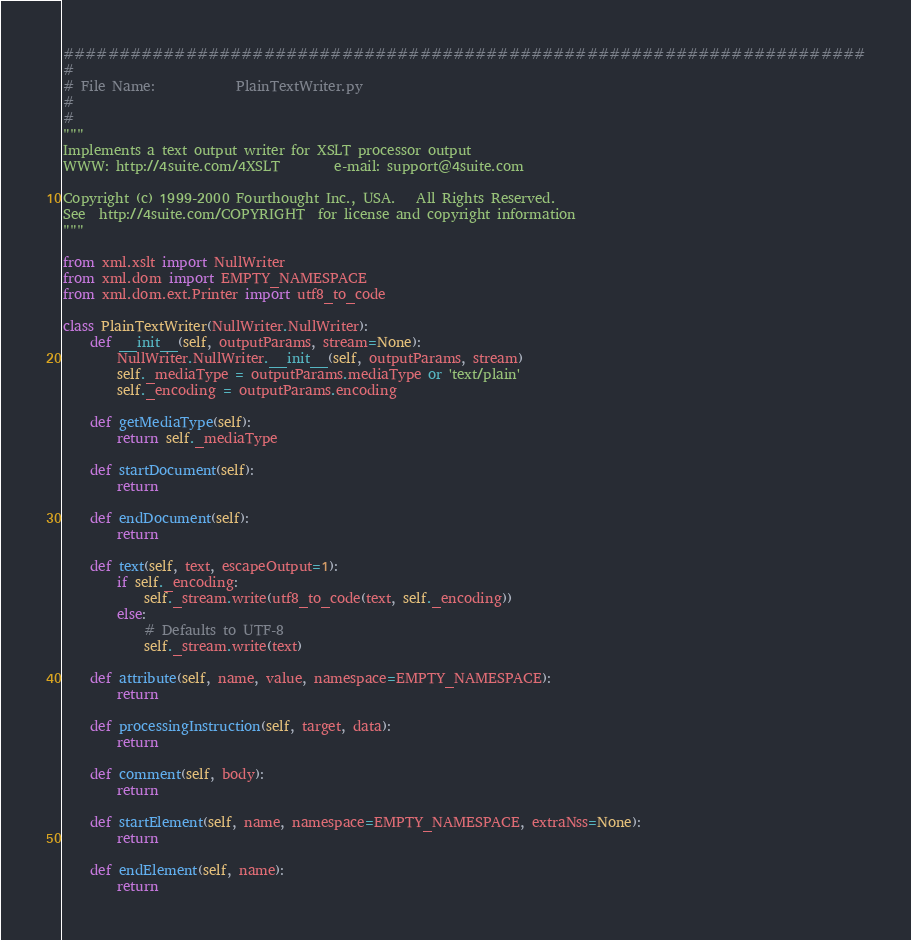<code> <loc_0><loc_0><loc_500><loc_500><_Python_>########################################################################
#
# File Name:            PlainTextWriter.py
#
#
"""
Implements a text output writer for XSLT processor output
WWW: http://4suite.com/4XSLT        e-mail: support@4suite.com

Copyright (c) 1999-2000 Fourthought Inc., USA.   All Rights Reserved.
See  http://4suite.com/COPYRIGHT  for license and copyright information
"""

from xml.xslt import NullWriter
from xml.dom import EMPTY_NAMESPACE
from xml.dom.ext.Printer import utf8_to_code

class PlainTextWriter(NullWriter.NullWriter):
    def __init__(self, outputParams, stream=None):
        NullWriter.NullWriter.__init__(self, outputParams, stream)
        self._mediaType = outputParams.mediaType or 'text/plain'
        self._encoding = outputParams.encoding
        
    def getMediaType(self):
        return self._mediaType
  
    def startDocument(self):
        return

    def endDocument(self):
        return
    
    def text(self, text, escapeOutput=1):
        if self._encoding:
            self._stream.write(utf8_to_code(text, self._encoding))
        else:
            # Defaults to UTF-8
            self._stream.write(text)
    
    def attribute(self, name, value, namespace=EMPTY_NAMESPACE):
        return

    def processingInstruction(self, target, data):
        return

    def comment(self, body):
        return

    def startElement(self, name, namespace=EMPTY_NAMESPACE, extraNss=None):
        return

    def endElement(self, name):
        return
</code> 